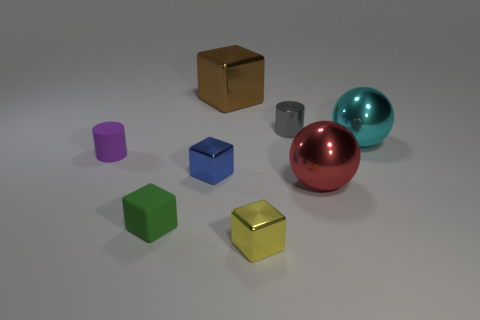Subtract all small matte cubes. How many cubes are left? 3 Subtract 2 cubes. How many cubes are left? 2 Subtract all cyan spheres. How many spheres are left? 1 Add 2 purple rubber cubes. How many objects exist? 10 Subtract all big cubes. Subtract all green matte cubes. How many objects are left? 6 Add 3 small green blocks. How many small green blocks are left? 4 Add 5 large red rubber spheres. How many large red rubber spheres exist? 5 Subtract 0 red cylinders. How many objects are left? 8 Subtract all balls. How many objects are left? 6 Subtract all blue blocks. Subtract all cyan cylinders. How many blocks are left? 3 